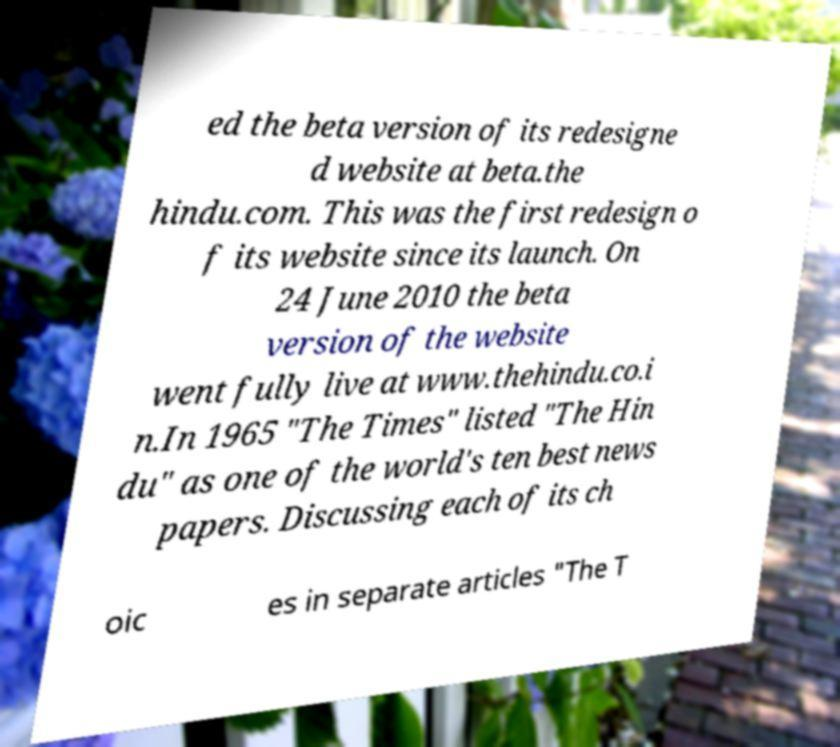Please identify and transcribe the text found in this image. ed the beta version of its redesigne d website at beta.the hindu.com. This was the first redesign o f its website since its launch. On 24 June 2010 the beta version of the website went fully live at www.thehindu.co.i n.In 1965 "The Times" listed "The Hin du" as one of the world's ten best news papers. Discussing each of its ch oic es in separate articles "The T 